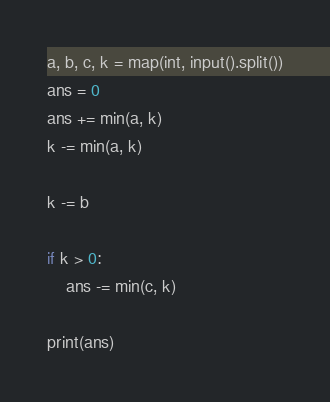<code> <loc_0><loc_0><loc_500><loc_500><_Python_>a, b, c, k = map(int, input().split())
ans = 0
ans += min(a, k)
k -= min(a, k)

k -= b

if k > 0:
    ans -= min(c, k)

print(ans)
</code> 